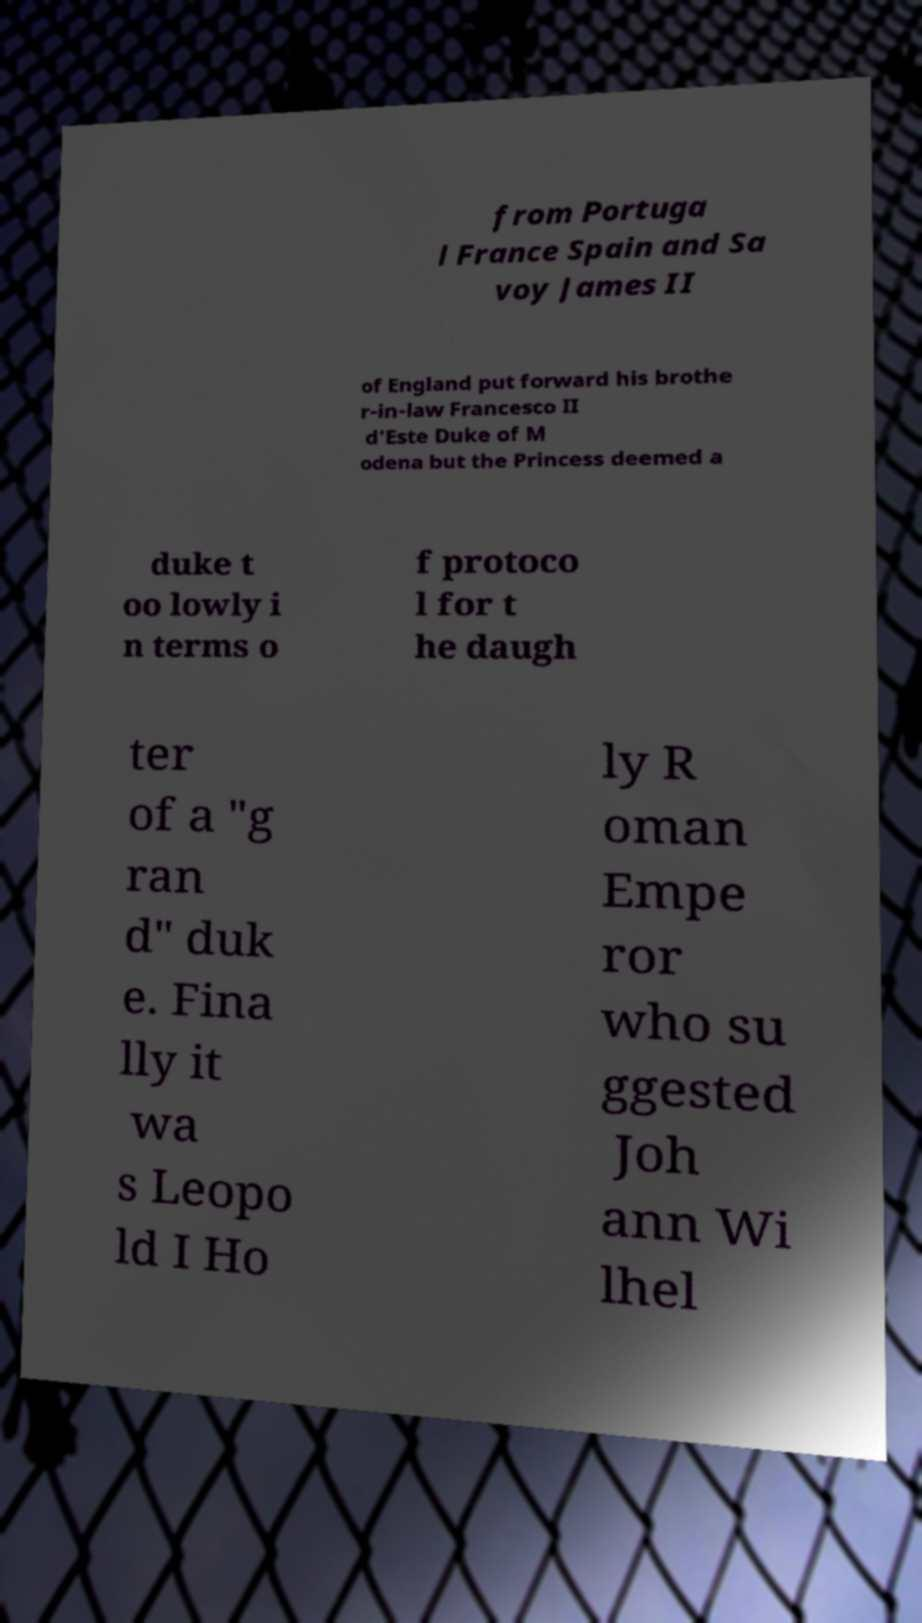Please identify and transcribe the text found in this image. from Portuga l France Spain and Sa voy James II of England put forward his brothe r-in-law Francesco II d'Este Duke of M odena but the Princess deemed a duke t oo lowly i n terms o f protoco l for t he daugh ter of a "g ran d" duk e. Fina lly it wa s Leopo ld I Ho ly R oman Empe ror who su ggested Joh ann Wi lhel 